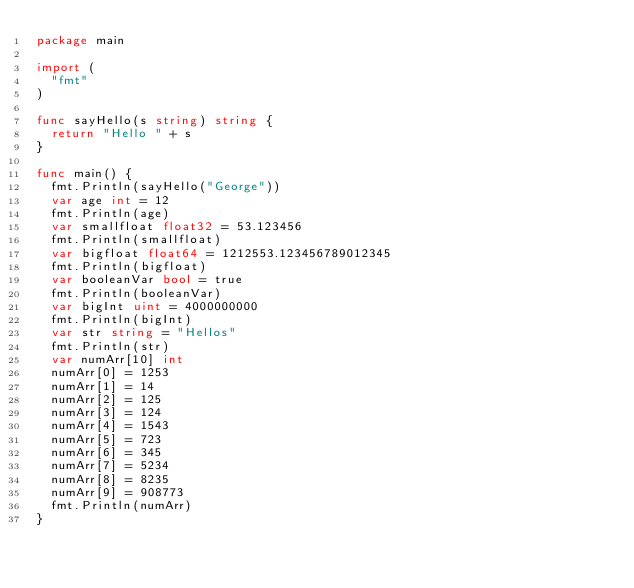<code> <loc_0><loc_0><loc_500><loc_500><_Go_>package main

import (
	"fmt"
)

func sayHello(s string) string {
	return "Hello " + s
}

func main() {
	fmt.Println(sayHello("George"))
	var age int = 12
	fmt.Println(age)
	var smallfloat float32 = 53.123456
	fmt.Println(smallfloat)
	var bigfloat float64 = 1212553.123456789012345
	fmt.Println(bigfloat)
	var booleanVar bool = true
	fmt.Println(booleanVar)
	var bigInt uint = 4000000000
	fmt.Println(bigInt)
	var str string = "Hellos"
	fmt.Println(str)
	var numArr[10] int
	numArr[0] = 1253
	numArr[1] = 14
	numArr[2] = 125
	numArr[3] = 124
	numArr[4] = 1543
	numArr[5] = 723
	numArr[6] = 345
	numArr[7] = 5234
	numArr[8] = 8235
	numArr[9] = 908773
	fmt.Println(numArr)
}
</code> 